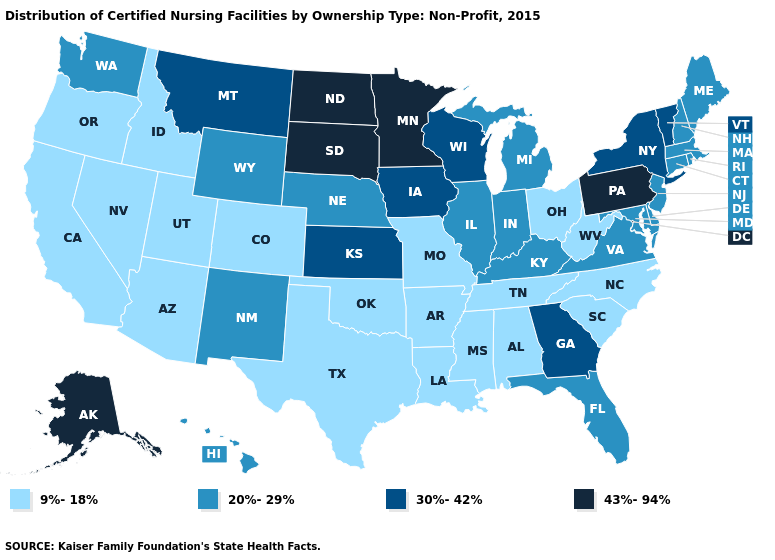What is the highest value in the West ?
Give a very brief answer. 43%-94%. What is the highest value in the MidWest ?
Write a very short answer. 43%-94%. Which states have the highest value in the USA?
Write a very short answer. Alaska, Minnesota, North Dakota, Pennsylvania, South Dakota. Which states hav the highest value in the Northeast?
Short answer required. Pennsylvania. Name the states that have a value in the range 43%-94%?
Keep it brief. Alaska, Minnesota, North Dakota, Pennsylvania, South Dakota. Is the legend a continuous bar?
Concise answer only. No. Does the first symbol in the legend represent the smallest category?
Write a very short answer. Yes. Does the first symbol in the legend represent the smallest category?
Answer briefly. Yes. Among the states that border Minnesota , which have the highest value?
Answer briefly. North Dakota, South Dakota. Name the states that have a value in the range 9%-18%?
Write a very short answer. Alabama, Arizona, Arkansas, California, Colorado, Idaho, Louisiana, Mississippi, Missouri, Nevada, North Carolina, Ohio, Oklahoma, Oregon, South Carolina, Tennessee, Texas, Utah, West Virginia. What is the highest value in the USA?
Answer briefly. 43%-94%. Which states have the lowest value in the MidWest?
Write a very short answer. Missouri, Ohio. What is the value of Georgia?
Keep it brief. 30%-42%. What is the lowest value in states that border Minnesota?
Keep it brief. 30%-42%. What is the lowest value in the South?
Answer briefly. 9%-18%. 